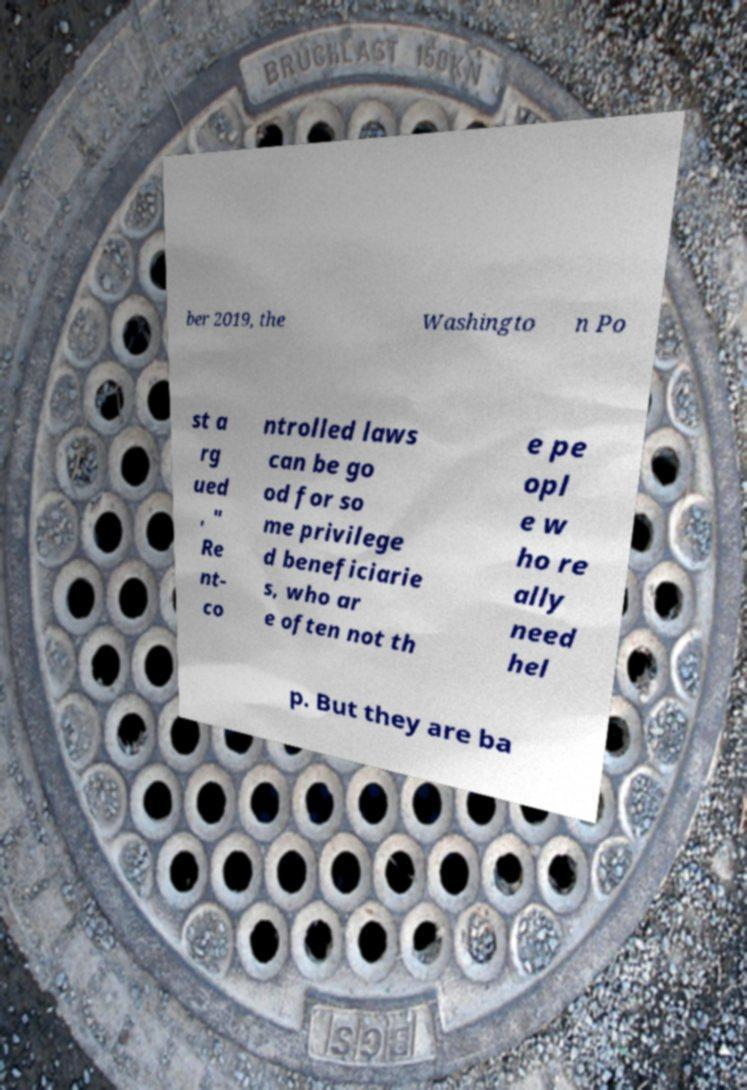Please identify and transcribe the text found in this image. ber 2019, the Washingto n Po st a rg ued , " Re nt- co ntrolled laws can be go od for so me privilege d beneficiarie s, who ar e often not th e pe opl e w ho re ally need hel p. But they are ba 